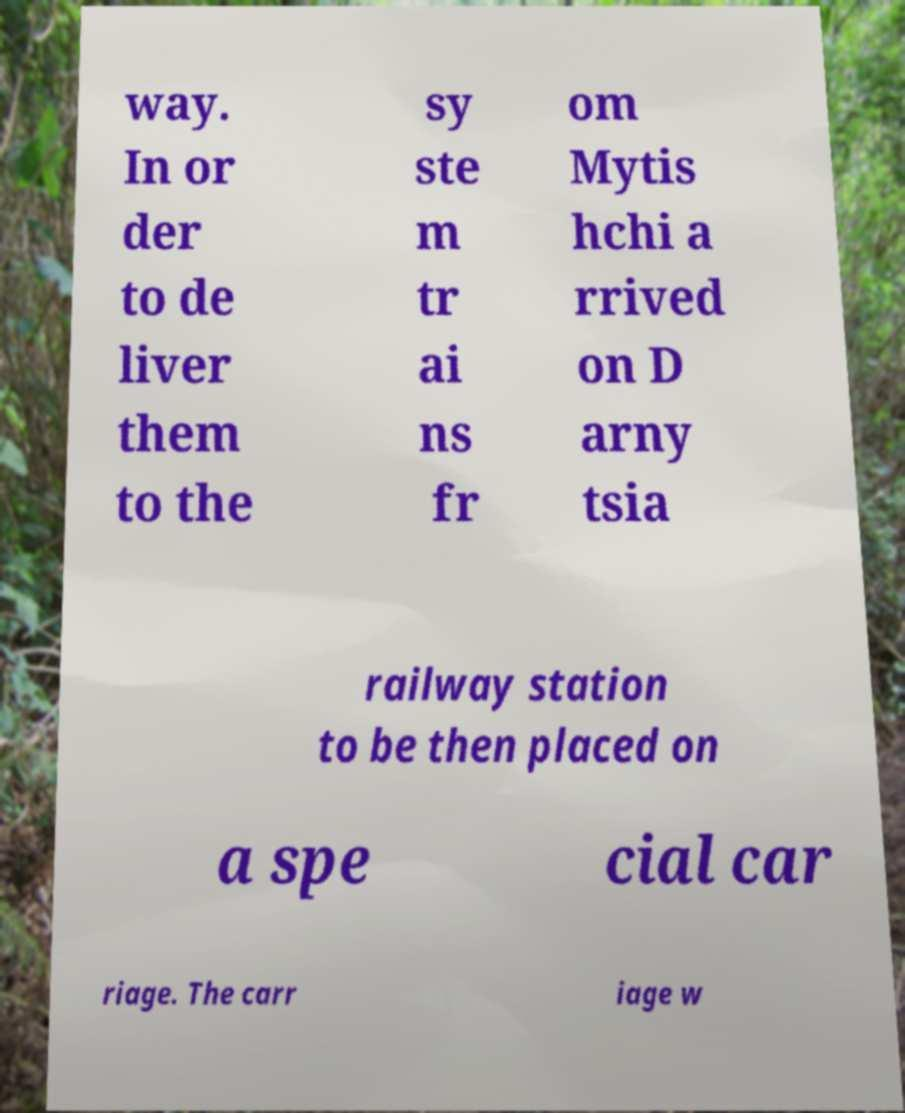There's text embedded in this image that I need extracted. Can you transcribe it verbatim? way. In or der to de liver them to the sy ste m tr ai ns fr om Mytis hchi a rrived on D arny tsia railway station to be then placed on a spe cial car riage. The carr iage w 